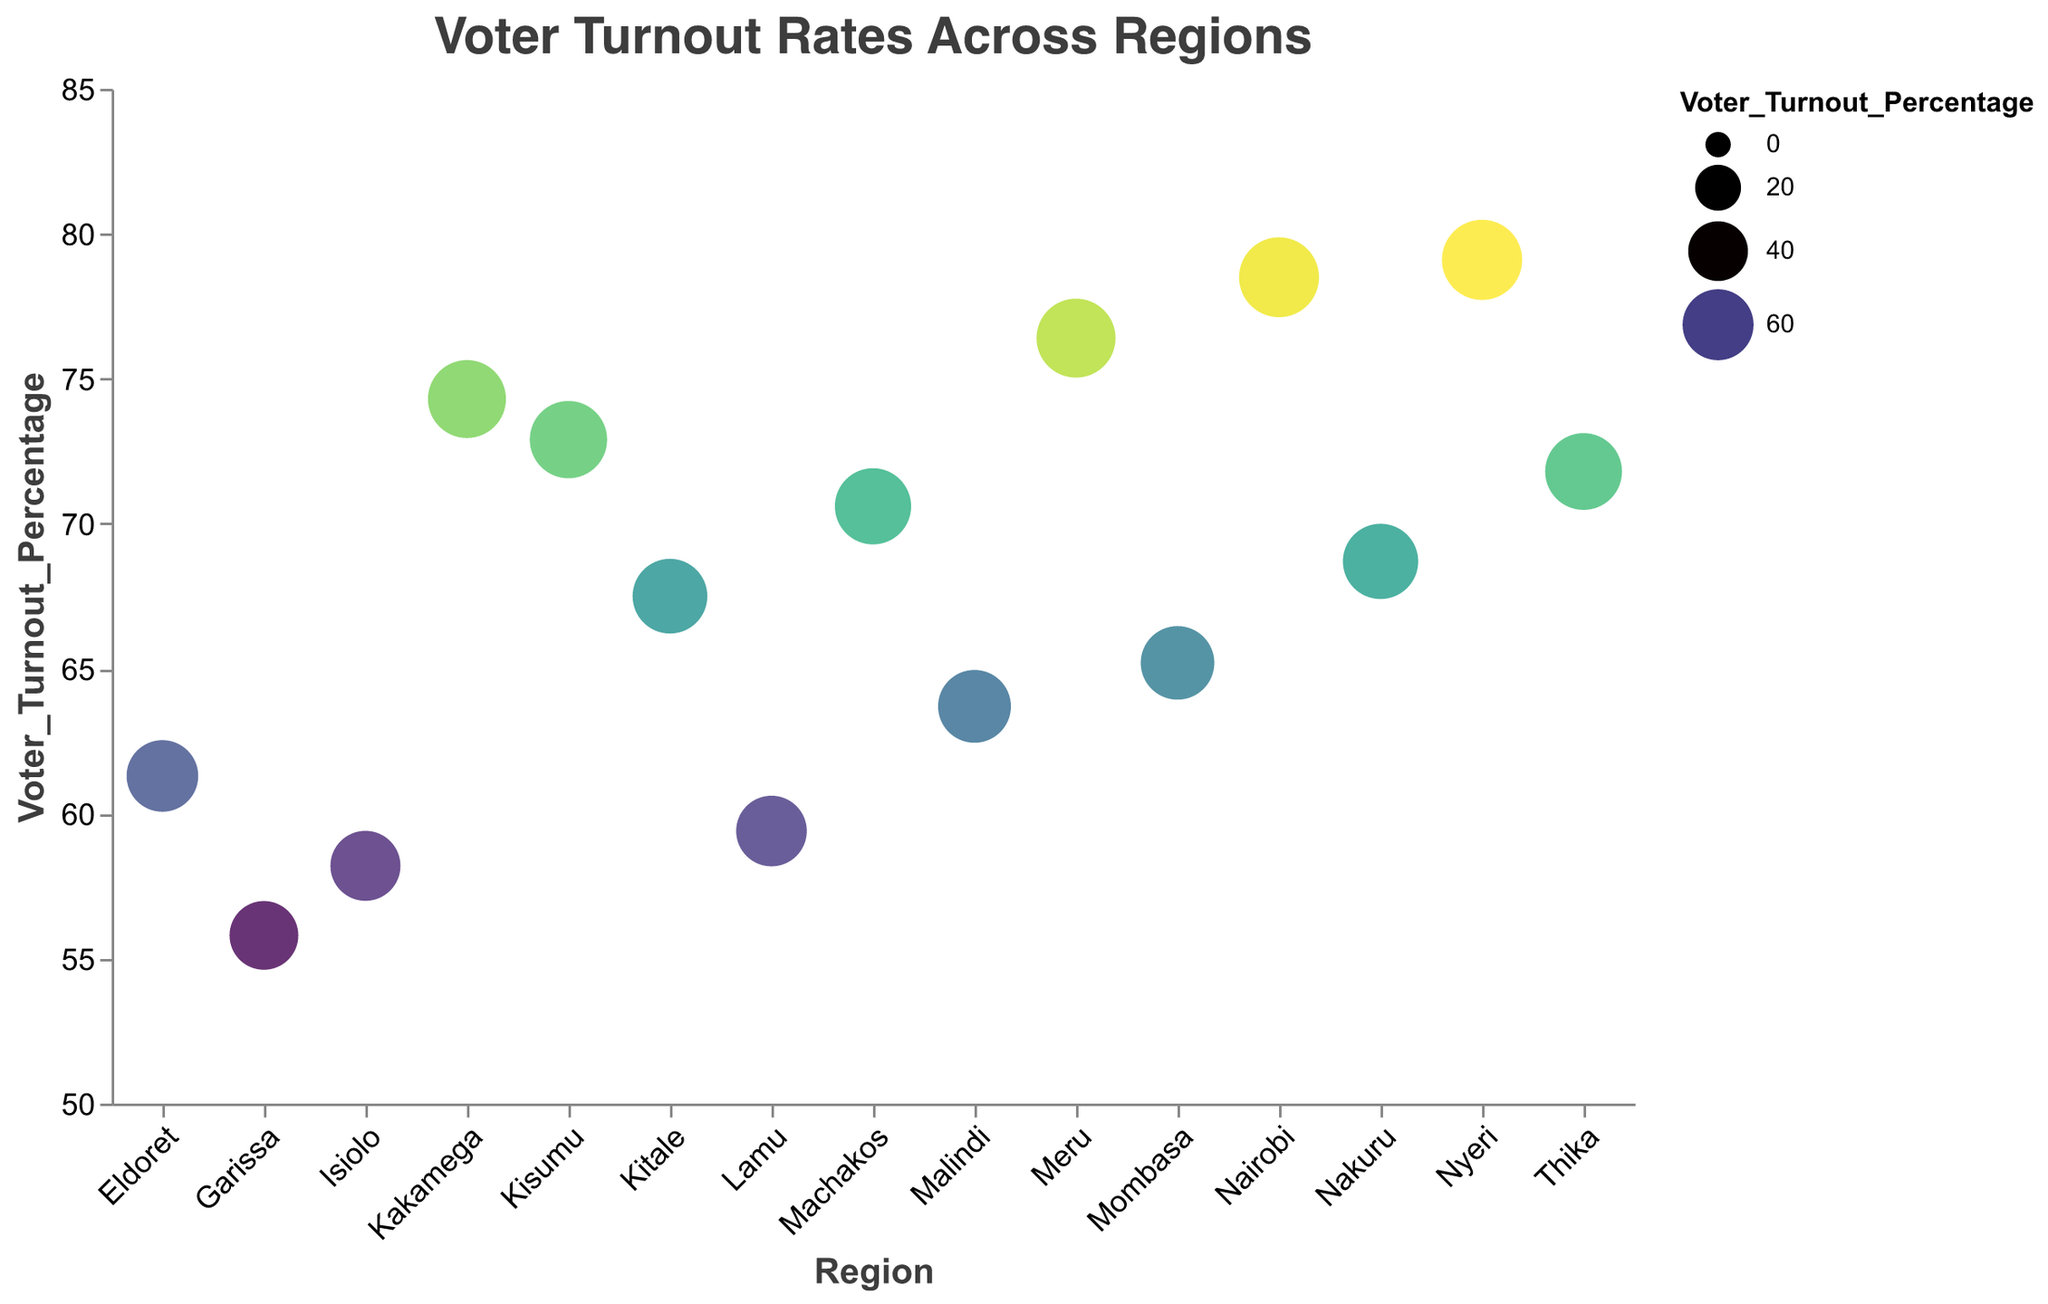What's the title of the plot? The title of the plot is prominently displayed at the top center.
Answer: Voter Turnout Rates Across Regions How many regions are represented in the plot? By counting the distinct regions displayed on the x-axis, we can determine the number of regions.
Answer: 15 Which region has the highest voter turnout percentage? The region with the largest circle and highest position on the y-axis represents the highest voter turnout percentage.
Answer: Nyeri Which region has the lowest voter turnout percentage? The region with the smallest circle and lowest position on the y-axis represents the lowest voter turnout percentage.
Answer: Garissa What is the voter turnout percentage for Nairobi? By identifying the circle corresponding to Nairobi and reading its y-axis position or tooltip information, we determine the voter turnout percentage.
Answer: 78.5% What is the difference in voter turnout between Nyeri and Garissa? First, identify the voter turnout percentages for Nyeri and Garissa. Then, subtract the value for Garissa from the value for Nyeri.
Answer: 79.1% - 55.8% = 23.3% What are the average voter turnout percentages across all regions? Sum the voter turnout percentages of all regions and divide by the number of regions (15) to get the average.
Answer: (78.5 + 65.2 + 72.9 + 68.7 + 61.3 + 79.1 + 70.6 + 55.8 + 74.3 + 59.4 + 63.7 + 71.8 + 67.5 + 58.2 + 76.4) / 15 = 68% How does Nairobi's voter turnout compare to that of Mombasa? Compare the y-axis positions or the percentages directly to determine which is higher.
Answer: Nairobi (78.5%) has a higher turnout than Mombasa (65.2%) Which regions have voter turnout percentages below 60%? Identify all regions with circles positioned below the 60% mark on the y-axis.
Answer: Garissa, Lamu, Isiolo How are the sizes of the circles related to the voter turnout percentages? By observing the plot, we note that larger circles correspond to higher voter turnout percentages, indicating a positive relationship between circle size and voter turnout.
Answer: Larger circles indicate higher percentages 